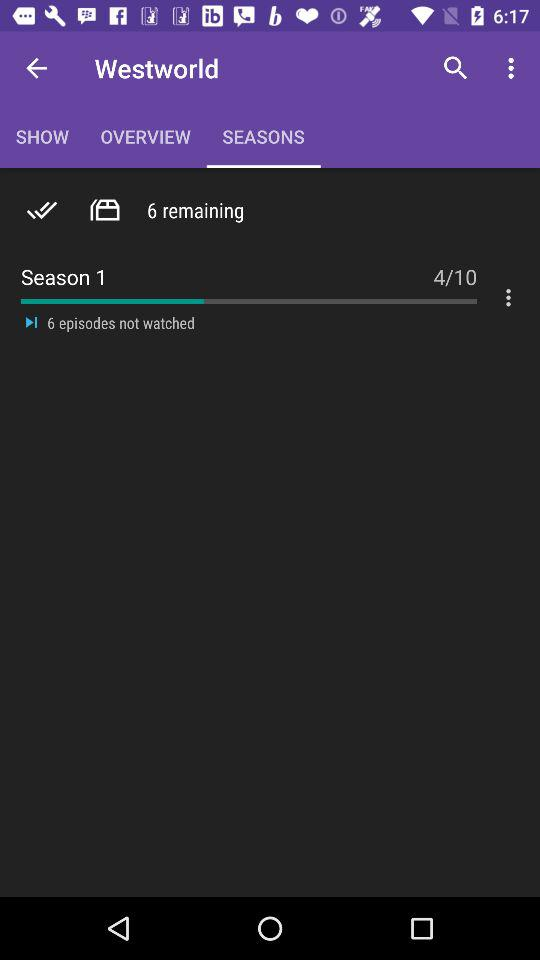How many episodes haven't been watched? There are 6 episodes that haven't been watched. 